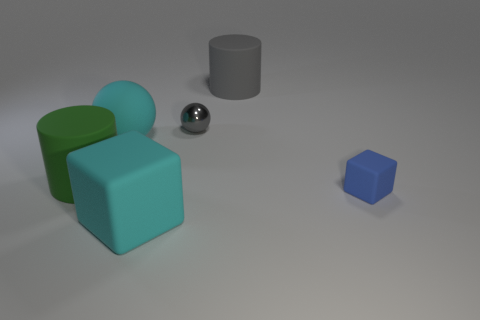Does the big green object have the same shape as the big matte thing that is to the right of the big rubber cube?
Your response must be concise. Yes. What number of other objects are there of the same material as the large green cylinder?
Your response must be concise. 4. There is a large cylinder that is to the right of the big cyan thing in front of the blue matte object that is behind the cyan cube; what is its color?
Provide a succinct answer. Gray. There is a cyan rubber thing left of the block that is on the left side of the shiny sphere; what shape is it?
Offer a terse response. Sphere. Is the number of cubes that are to the left of the tiny blue rubber cube greater than the number of red shiny cylinders?
Provide a succinct answer. Yes. There is a small object on the right side of the big gray matte cylinder; does it have the same shape as the metallic object?
Provide a short and direct response. No. Is there a big thing that has the same shape as the small metal thing?
Your response must be concise. Yes. What number of objects are either big cyan matte things on the left side of the cyan matte block or big cyan matte things?
Offer a terse response. 2. Are there more tiny purple cylinders than balls?
Your answer should be very brief. No. Is there a cyan ball that has the same size as the gray matte thing?
Offer a very short reply. Yes. 